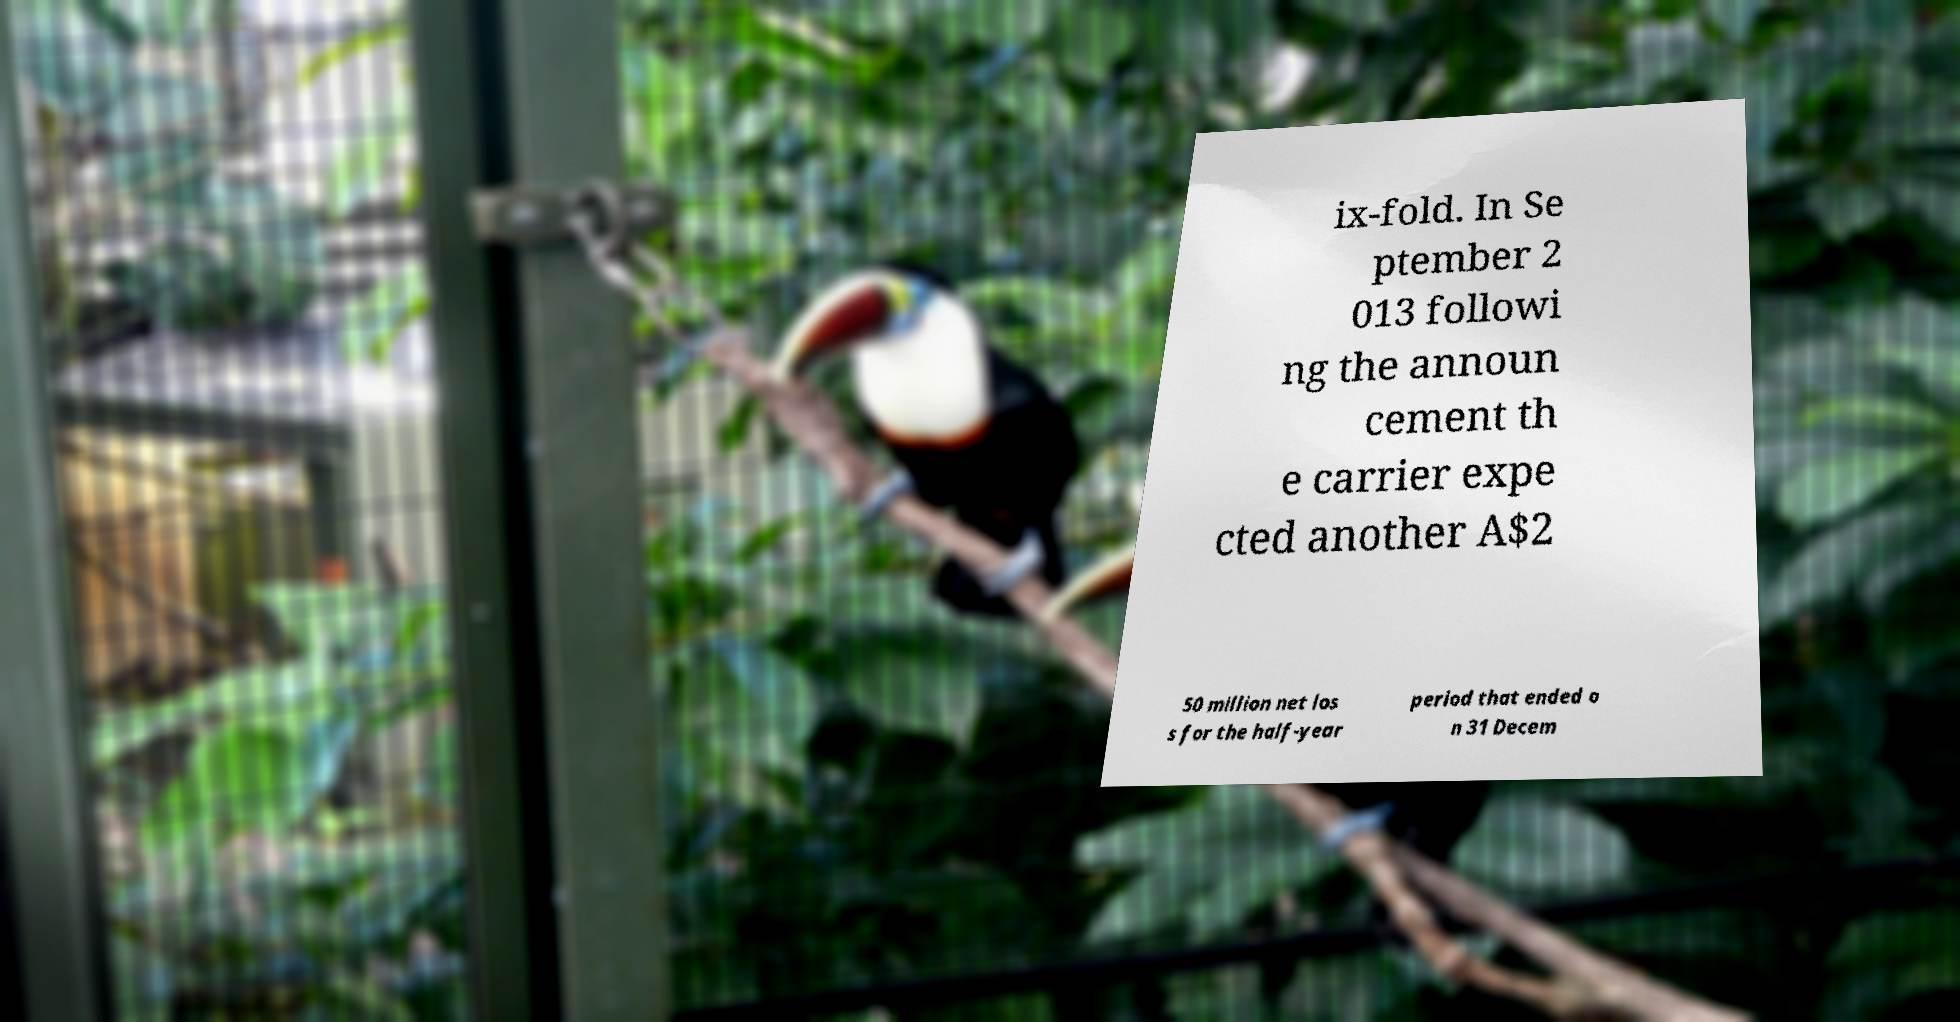For documentation purposes, I need the text within this image transcribed. Could you provide that? ix-fold. In Se ptember 2 013 followi ng the announ cement th e carrier expe cted another A$2 50 million net los s for the half-year period that ended o n 31 Decem 